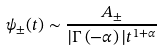Convert formula to latex. <formula><loc_0><loc_0><loc_500><loc_500>\psi _ { \pm } ( t ) \sim { \frac { A _ { \pm } } { | \Gamma \left ( - \alpha \right ) | t ^ { 1 + \alpha } } }</formula> 